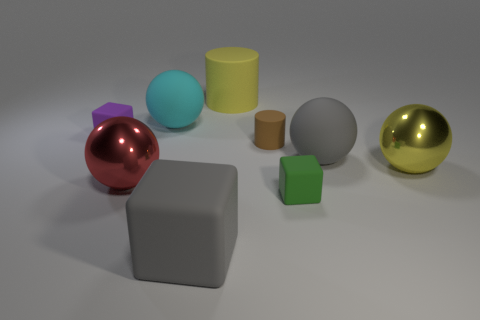Add 1 tiny yellow things. How many objects exist? 10 Subtract all cubes. How many objects are left? 6 Add 5 tiny rubber cubes. How many tiny rubber cubes exist? 7 Subtract 1 gray cubes. How many objects are left? 8 Subtract all large gray rubber spheres. Subtract all green blocks. How many objects are left? 7 Add 1 large yellow things. How many large yellow things are left? 3 